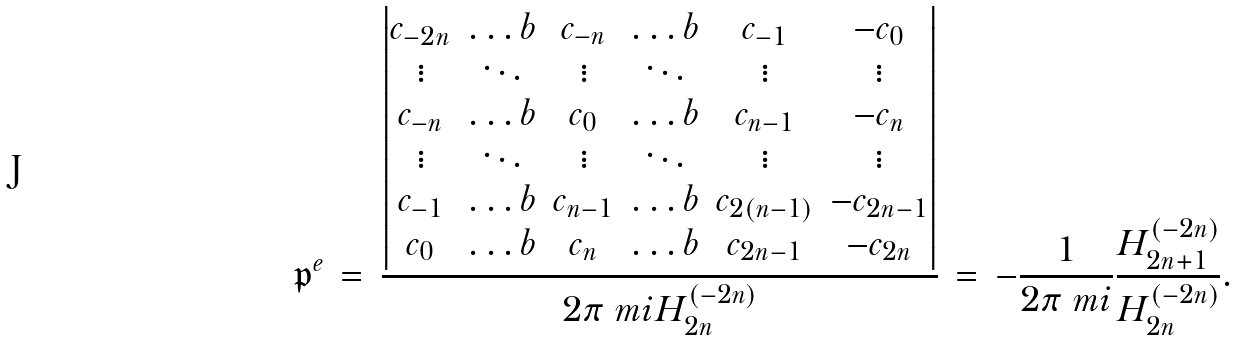<formula> <loc_0><loc_0><loc_500><loc_500>\mathfrak { p } ^ { e } \, = \, \frac { \begin{vmatrix} c _ { - 2 n } & \dots b & c _ { - n } & \dots b & c _ { - 1 } & - c _ { 0 } \\ \vdots & \ddots & \vdots & \ddots & \vdots & \vdots \\ c _ { - n } & \dots b & c _ { 0 } & \dots b & c _ { n - 1 } & - c _ { n } \\ \vdots & \ddots & \vdots & \ddots & \vdots & \vdots \\ c _ { - 1 } & \dots b & c _ { n - 1 } & \dots b & c _ { 2 ( n - 1 ) } & - c _ { 2 n - 1 } \\ c _ { 0 } & \dots b & c _ { n } & \dots b & c _ { 2 n - 1 } & - c _ { 2 n } \end{vmatrix} } { 2 \pi \ m i H ^ { ( - 2 n ) } _ { 2 n } } \, = \, - \frac { 1 } { 2 \pi \ m i } \frac { H ^ { ( - 2 n ) } _ { 2 n + 1 } } { H ^ { ( - 2 n ) } _ { 2 n } } .</formula> 